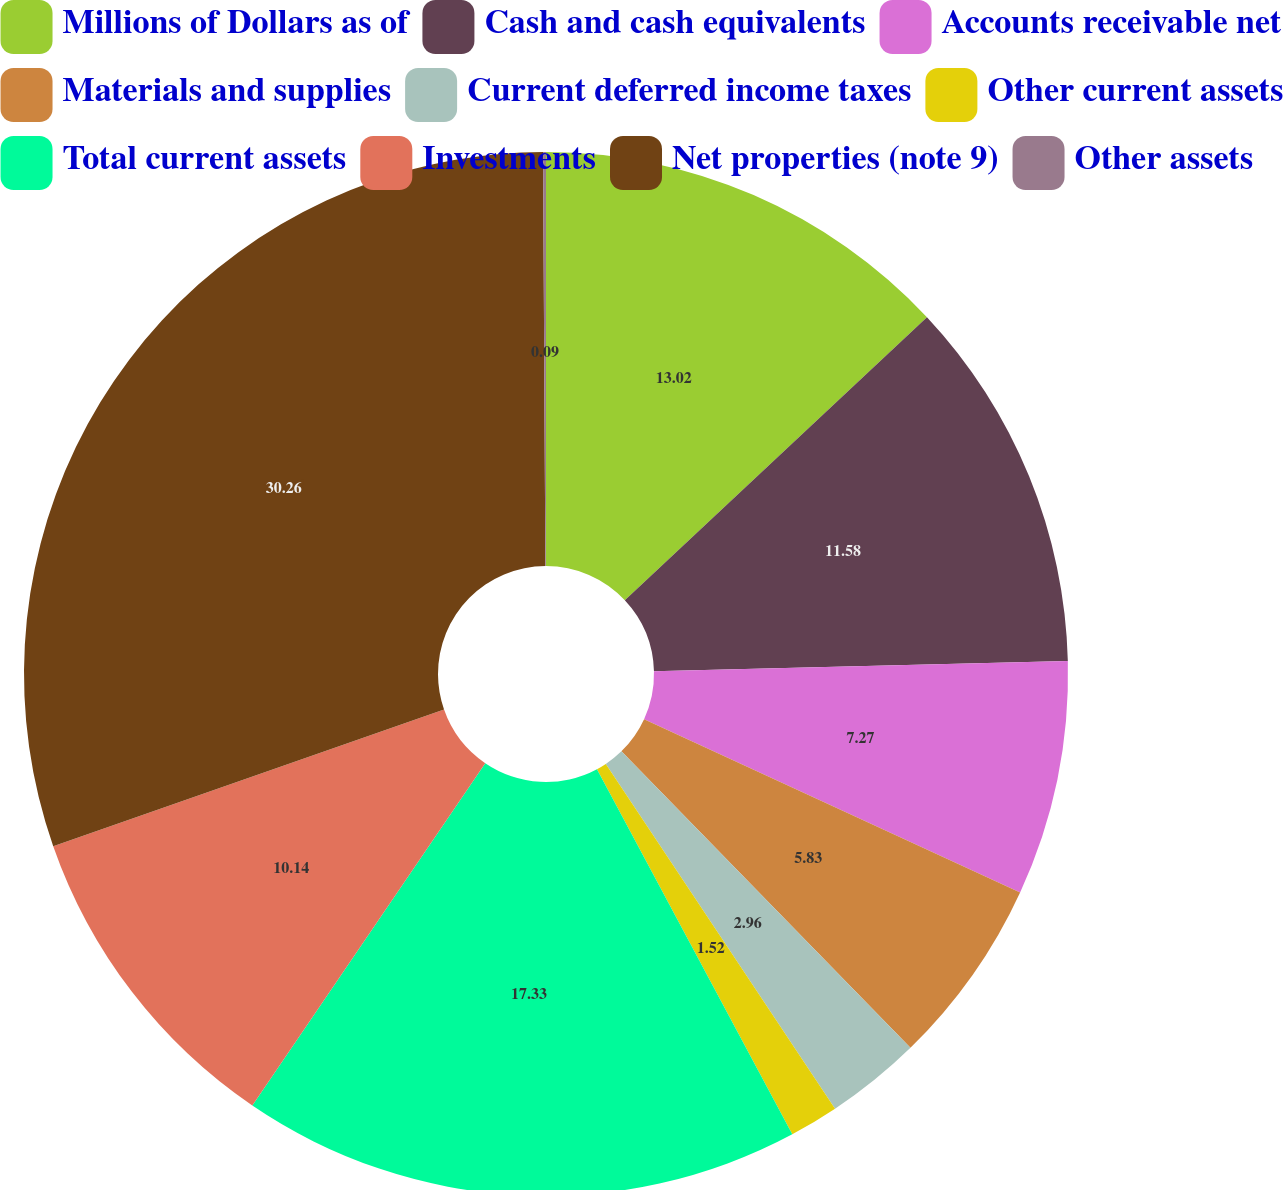Convert chart. <chart><loc_0><loc_0><loc_500><loc_500><pie_chart><fcel>Millions of Dollars as of<fcel>Cash and cash equivalents<fcel>Accounts receivable net<fcel>Materials and supplies<fcel>Current deferred income taxes<fcel>Other current assets<fcel>Total current assets<fcel>Investments<fcel>Net properties (note 9)<fcel>Other assets<nl><fcel>13.02%<fcel>11.58%<fcel>7.27%<fcel>5.83%<fcel>2.96%<fcel>1.52%<fcel>17.33%<fcel>10.14%<fcel>30.26%<fcel>0.09%<nl></chart> 